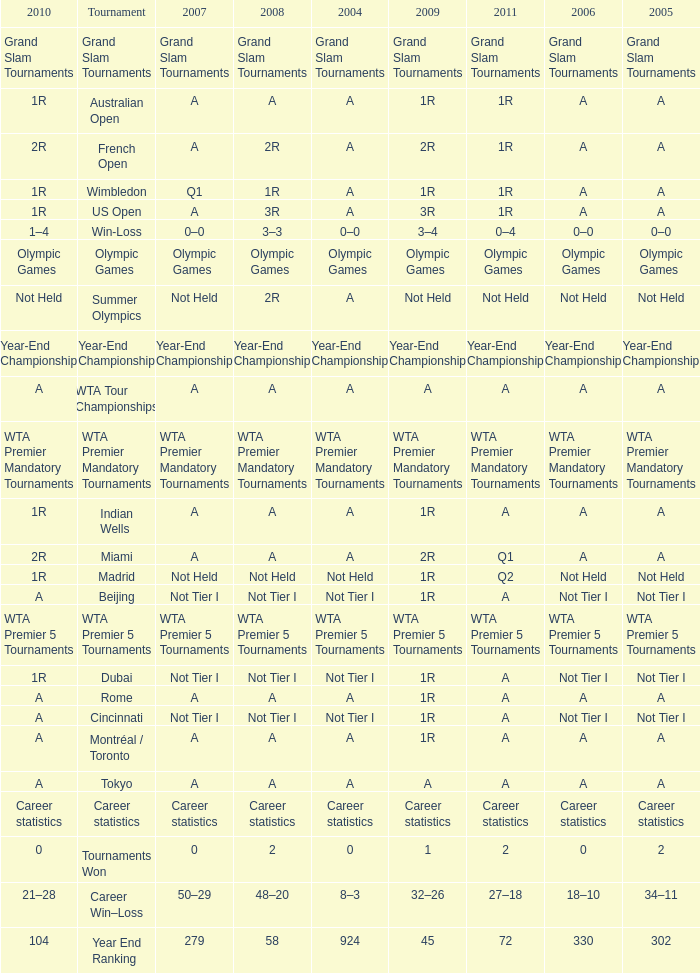What is 2004, when 2008 is "WTA Premier 5 Tournaments"? WTA Premier 5 Tournaments. 